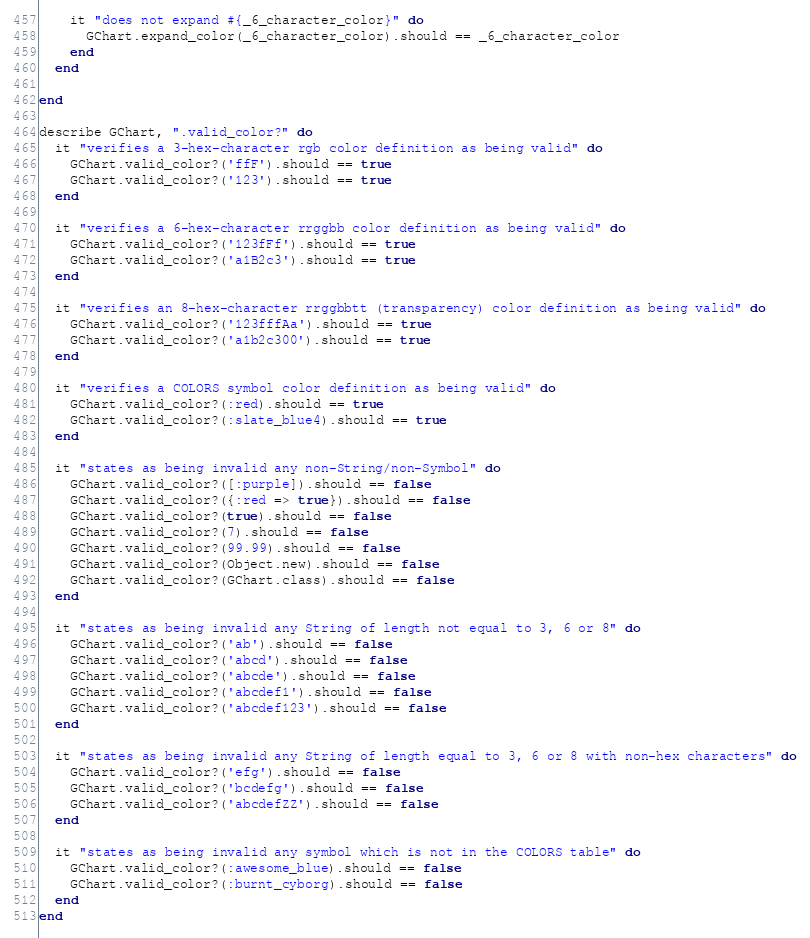<code> <loc_0><loc_0><loc_500><loc_500><_Ruby_>    it "does not expand #{_6_character_color}" do
      GChart.expand_color(_6_character_color).should == _6_character_color
    end
  end

end

describe GChart, ".valid_color?" do
  it "verifies a 3-hex-character rgb color definition as being valid" do
    GChart.valid_color?('ffF').should == true
    GChart.valid_color?('123').should == true
  end

  it "verifies a 6-hex-character rrggbb color definition as being valid" do
    GChart.valid_color?('123fFf').should == true
    GChart.valid_color?('a1B2c3').should == true
  end

  it "verifies an 8-hex-character rrggbbtt (transparency) color definition as being valid" do
    GChart.valid_color?('123fffAa').should == true
    GChart.valid_color?('a1b2c300').should == true
  end

  it "verifies a COLORS symbol color definition as being valid" do
    GChart.valid_color?(:red).should == true
    GChart.valid_color?(:slate_blue4).should == true
  end

  it "states as being invalid any non-String/non-Symbol" do
    GChart.valid_color?([:purple]).should == false
    GChart.valid_color?({:red => true}).should == false
    GChart.valid_color?(true).should == false
    GChart.valid_color?(7).should == false
    GChart.valid_color?(99.99).should == false
    GChart.valid_color?(Object.new).should == false
    GChart.valid_color?(GChart.class).should == false
  end

  it "states as being invalid any String of length not equal to 3, 6 or 8" do
    GChart.valid_color?('ab').should == false
    GChart.valid_color?('abcd').should == false
    GChart.valid_color?('abcde').should == false
    GChart.valid_color?('abcdef1').should == false
    GChart.valid_color?('abcdef123').should == false
  end

  it "states as being invalid any String of length equal to 3, 6 or 8 with non-hex characters" do
    GChart.valid_color?('efg').should == false
    GChart.valid_color?('bcdefg').should == false
    GChart.valid_color?('abcdefZZ').should == false
  end

  it "states as being invalid any symbol which is not in the COLORS table" do
    GChart.valid_color?(:awesome_blue).should == false
    GChart.valid_color?(:burnt_cyborg).should == false
  end
end
</code> 